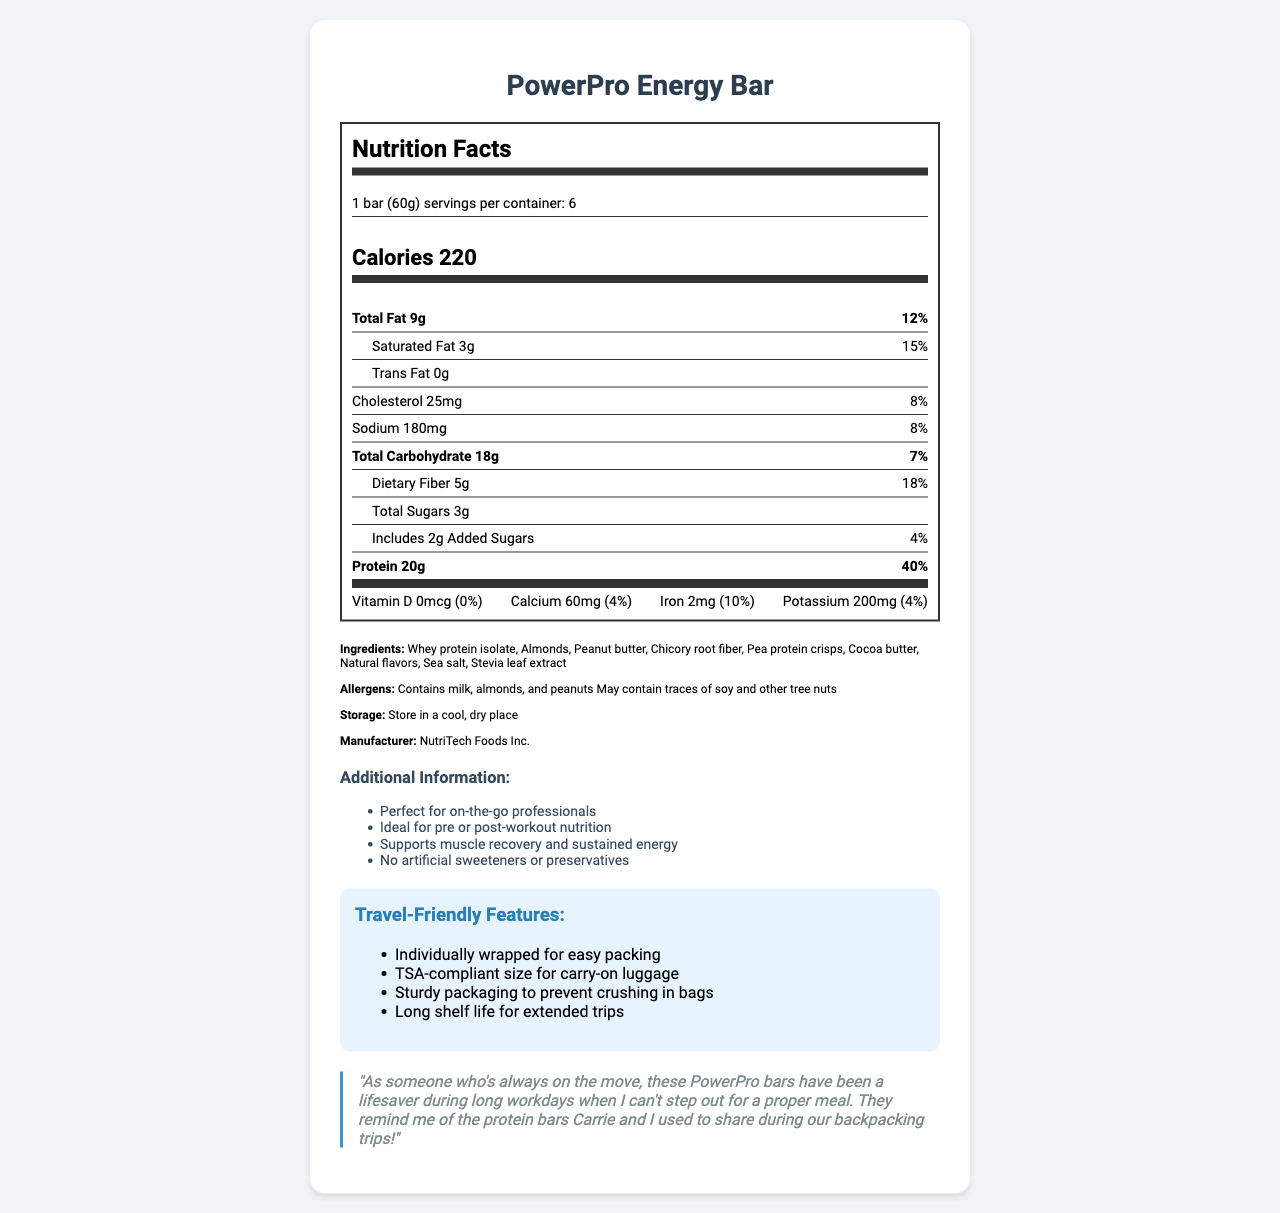what is the serving size of the PowerPro Energy Bar? The serving size is clearly stated under the Nutrition Facts header.
Answer: 1 bar (60g) how many calories does one PowerPro Energy Bar provide? The calories per serving are mentioned in the calorie info section of the nutrition label.
Answer: 220 what is the protein content per serving of PowerPro Energy Bar? The protein amount is shown under the bold nutrient info section.
Answer: 20g how much total fat is in one PowerPro Energy Bar? The total fat amount is listed under the bold nutrient info section.
Answer: 9g how many servings are there per container? The number of servings per container is mentioned in the serving info section.
Answer: 6 what percentage of daily value is the saturated fat content in one bar? The daily value percentage of saturated fat is mentioned next to the saturated fat amount.
Answer: 15% how much added sugars are in one PowerPro Energy Bar? The amount of added sugars is listed under the sub-nutrient section.
Answer: 2g are there any artificial sweeteners or preservatives in the PowerPro Energy Bar? The additional info section states there are no artificial sweeteners or preservatives.
Answer: No what allergens are present in the PowerPro Energy Bar? A. Peanuts and tree nuts B. Soy and wheat C. Milk and almonds D. Gluten and sesame The allergens listed include milk, almonds, and peanuts. Options C correctly captures these allergens.
Answer: C how should the PowerPro Energy Bar be stored? A. Refrigerate B. Store in a cool, dry place C. Store in a warm place D. Freeze The storage instructions indicate to store in a cool, dry place.
Answer: B does the PowerPro Energy Bar contain iron? The amount of iron is listed in the vitamins section, showing 2mg of iron.
Answer: Yes will you receive 100% of your daily value of calcium if you eat one PowerPro Energy Bar? The daily value for calcium in one bar is only 4%.
Answer: No who is the manufacturer of the PowerPro Energy Bar? The manufacturer's name is mentioned in the ingredients section.
Answer: NutriTech Foods Inc. describe the main features and benefits of the PowerPro Energy Bar based on the document The document provides comprehensive details on nutritional content, ingredients, allergens, storage directions, manufacturer information, additional benefits, and travel-friendly features.
Answer: The PowerPro Energy Bar is designed for busy professionals, providing high protein (20g) and low carbohydrate (18g) content per serving. It includes travel-friendly features like sturdy and TSA-compliant packaging. The bar supports muscle recovery and sustained energy, and it contains no artificial sweeteners or preservatives. It is produced by NutriTech Foods Inc. and should be stored in a cool, dry place. how many different ingredients are listed in the PowerPro Energy Bar? The ingredients section lists whey protein isolate, almonds, peanut butter, chicory root fiber, pea protein crisps, cocoa butter, natural flavors, sea salt, stevia leaf extract.
Answer: 9 can the amount of Vitamin D in the PowerPro Energy Bar meet the daily requirement? The nutrition label shows 0% daily value for Vitamin D, meaning it does not contribute to the daily requirement.
Answer: No why would someone on-the-go choose the PowerPro Energy Bar? The additional info and travel-friendly sections emphasize these benefits.
Answer: It is convenient for busy professionals, offers high protein content, supports muscle recovery and sustained energy, and has travel-friendly features like TSA-compliant size and sturdy packaging. how often did the testimonial mention traveling with the PowerPro Energy Bar? The testimonial references using the bars during long workdays and comparing them to backpacking trips with Carrie.
Answer: Once what is the exact amount of potassium in the PowerPro Energy Bar? The potassium amount is listed in the vitamins section with 200mg.
Answer: 200mg how much daily dietary fiber can one gain from a PowerPro Energy Bar? The daily value percentage of dietary fiber is mentioned under the sub-nutrient section.
Answer: 18% does the document mention if the bar is gluten-free? The document does not provide any information about whether the bar is gluten-free or not.
Answer: Not enough information 